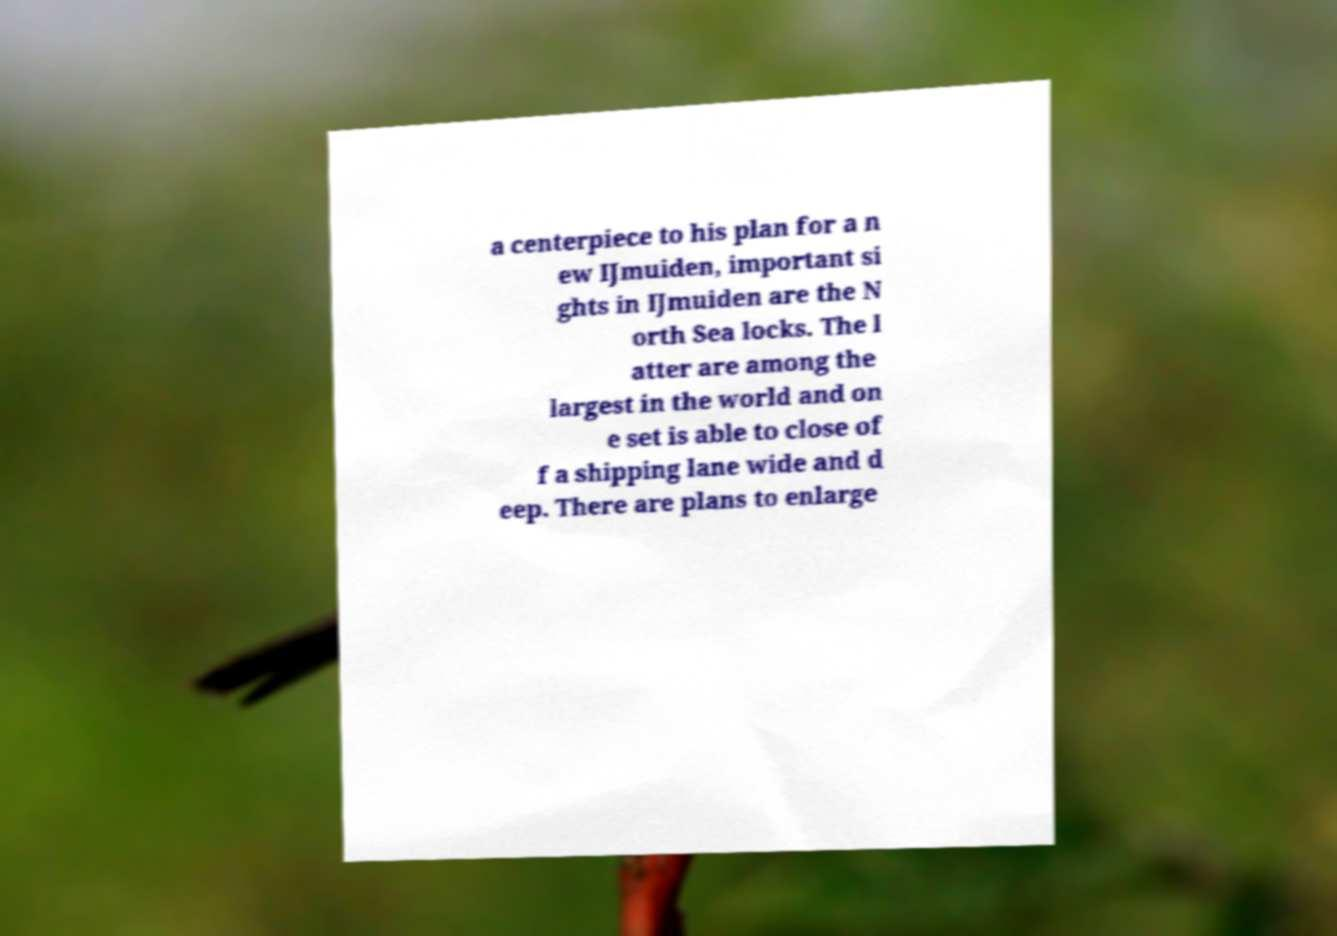Can you accurately transcribe the text from the provided image for me? a centerpiece to his plan for a n ew IJmuiden, important si ghts in IJmuiden are the N orth Sea locks. The l atter are among the largest in the world and on e set is able to close of f a shipping lane wide and d eep. There are plans to enlarge 